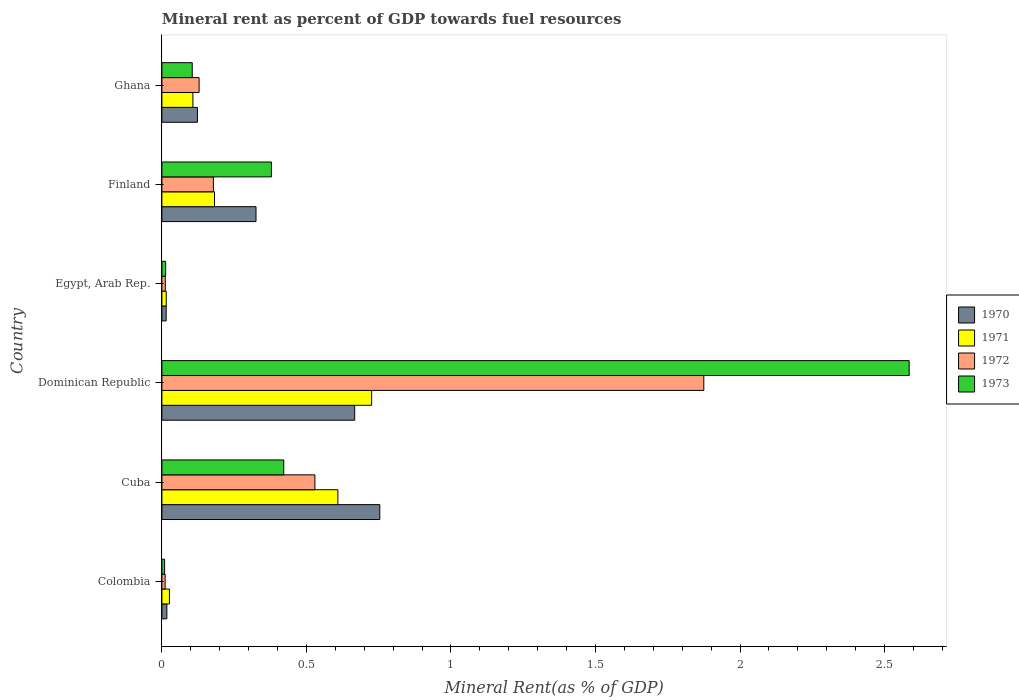How many different coloured bars are there?
Offer a very short reply. 4. How many groups of bars are there?
Offer a very short reply. 6. How many bars are there on the 3rd tick from the bottom?
Offer a very short reply. 4. What is the mineral rent in 1970 in Cuba?
Make the answer very short. 0.75. Across all countries, what is the maximum mineral rent in 1971?
Your answer should be very brief. 0.73. Across all countries, what is the minimum mineral rent in 1971?
Your response must be concise. 0.02. In which country was the mineral rent in 1972 maximum?
Provide a short and direct response. Dominican Republic. In which country was the mineral rent in 1971 minimum?
Provide a succinct answer. Egypt, Arab Rep. What is the total mineral rent in 1972 in the graph?
Your answer should be compact. 2.73. What is the difference between the mineral rent in 1971 in Cuba and that in Ghana?
Offer a very short reply. 0.5. What is the difference between the mineral rent in 1972 in Ghana and the mineral rent in 1971 in Cuba?
Make the answer very short. -0.48. What is the average mineral rent in 1972 per country?
Keep it short and to the point. 0.46. What is the difference between the mineral rent in 1972 and mineral rent in 1973 in Cuba?
Provide a succinct answer. 0.11. What is the ratio of the mineral rent in 1973 in Colombia to that in Egypt, Arab Rep.?
Provide a short and direct response. 0.72. Is the difference between the mineral rent in 1972 in Egypt, Arab Rep. and Ghana greater than the difference between the mineral rent in 1973 in Egypt, Arab Rep. and Ghana?
Offer a very short reply. No. What is the difference between the highest and the second highest mineral rent in 1971?
Make the answer very short. 0.12. What is the difference between the highest and the lowest mineral rent in 1971?
Make the answer very short. 0.71. Is the sum of the mineral rent in 1971 in Dominican Republic and Finland greater than the maximum mineral rent in 1973 across all countries?
Your answer should be very brief. No. Is it the case that in every country, the sum of the mineral rent in 1973 and mineral rent in 1971 is greater than the sum of mineral rent in 1970 and mineral rent in 1972?
Your answer should be compact. No. Are all the bars in the graph horizontal?
Provide a succinct answer. Yes. What is the difference between two consecutive major ticks on the X-axis?
Provide a short and direct response. 0.5. What is the title of the graph?
Your answer should be very brief. Mineral rent as percent of GDP towards fuel resources. Does "1982" appear as one of the legend labels in the graph?
Give a very brief answer. No. What is the label or title of the X-axis?
Provide a short and direct response. Mineral Rent(as % of GDP). What is the label or title of the Y-axis?
Offer a very short reply. Country. What is the Mineral Rent(as % of GDP) in 1970 in Colombia?
Provide a short and direct response. 0.02. What is the Mineral Rent(as % of GDP) in 1971 in Colombia?
Give a very brief answer. 0.03. What is the Mineral Rent(as % of GDP) of 1972 in Colombia?
Make the answer very short. 0.01. What is the Mineral Rent(as % of GDP) of 1973 in Colombia?
Provide a succinct answer. 0.01. What is the Mineral Rent(as % of GDP) in 1970 in Cuba?
Provide a succinct answer. 0.75. What is the Mineral Rent(as % of GDP) in 1971 in Cuba?
Provide a short and direct response. 0.61. What is the Mineral Rent(as % of GDP) in 1972 in Cuba?
Your answer should be compact. 0.53. What is the Mineral Rent(as % of GDP) of 1973 in Cuba?
Give a very brief answer. 0.42. What is the Mineral Rent(as % of GDP) in 1970 in Dominican Republic?
Offer a very short reply. 0.67. What is the Mineral Rent(as % of GDP) in 1971 in Dominican Republic?
Offer a very short reply. 0.73. What is the Mineral Rent(as % of GDP) of 1972 in Dominican Republic?
Offer a terse response. 1.87. What is the Mineral Rent(as % of GDP) of 1973 in Dominican Republic?
Your response must be concise. 2.59. What is the Mineral Rent(as % of GDP) of 1970 in Egypt, Arab Rep.?
Offer a terse response. 0.01. What is the Mineral Rent(as % of GDP) of 1971 in Egypt, Arab Rep.?
Offer a terse response. 0.02. What is the Mineral Rent(as % of GDP) of 1972 in Egypt, Arab Rep.?
Your answer should be compact. 0.01. What is the Mineral Rent(as % of GDP) in 1973 in Egypt, Arab Rep.?
Make the answer very short. 0.01. What is the Mineral Rent(as % of GDP) in 1970 in Finland?
Make the answer very short. 0.33. What is the Mineral Rent(as % of GDP) of 1971 in Finland?
Offer a very short reply. 0.18. What is the Mineral Rent(as % of GDP) of 1972 in Finland?
Your answer should be compact. 0.18. What is the Mineral Rent(as % of GDP) in 1973 in Finland?
Ensure brevity in your answer.  0.38. What is the Mineral Rent(as % of GDP) of 1970 in Ghana?
Your response must be concise. 0.12. What is the Mineral Rent(as % of GDP) in 1971 in Ghana?
Provide a short and direct response. 0.11. What is the Mineral Rent(as % of GDP) in 1972 in Ghana?
Your answer should be compact. 0.13. What is the Mineral Rent(as % of GDP) in 1973 in Ghana?
Offer a very short reply. 0.1. Across all countries, what is the maximum Mineral Rent(as % of GDP) of 1970?
Give a very brief answer. 0.75. Across all countries, what is the maximum Mineral Rent(as % of GDP) of 1971?
Your answer should be compact. 0.73. Across all countries, what is the maximum Mineral Rent(as % of GDP) of 1972?
Your answer should be very brief. 1.87. Across all countries, what is the maximum Mineral Rent(as % of GDP) in 1973?
Provide a short and direct response. 2.59. Across all countries, what is the minimum Mineral Rent(as % of GDP) in 1970?
Your answer should be compact. 0.01. Across all countries, what is the minimum Mineral Rent(as % of GDP) in 1971?
Provide a succinct answer. 0.02. Across all countries, what is the minimum Mineral Rent(as % of GDP) of 1972?
Offer a terse response. 0.01. Across all countries, what is the minimum Mineral Rent(as % of GDP) in 1973?
Your answer should be compact. 0.01. What is the total Mineral Rent(as % of GDP) of 1970 in the graph?
Give a very brief answer. 1.9. What is the total Mineral Rent(as % of GDP) in 1971 in the graph?
Your answer should be compact. 1.66. What is the total Mineral Rent(as % of GDP) of 1972 in the graph?
Your response must be concise. 2.73. What is the total Mineral Rent(as % of GDP) of 1973 in the graph?
Keep it short and to the point. 3.51. What is the difference between the Mineral Rent(as % of GDP) of 1970 in Colombia and that in Cuba?
Give a very brief answer. -0.74. What is the difference between the Mineral Rent(as % of GDP) in 1971 in Colombia and that in Cuba?
Provide a short and direct response. -0.58. What is the difference between the Mineral Rent(as % of GDP) of 1972 in Colombia and that in Cuba?
Keep it short and to the point. -0.52. What is the difference between the Mineral Rent(as % of GDP) in 1973 in Colombia and that in Cuba?
Make the answer very short. -0.41. What is the difference between the Mineral Rent(as % of GDP) in 1970 in Colombia and that in Dominican Republic?
Ensure brevity in your answer.  -0.65. What is the difference between the Mineral Rent(as % of GDP) of 1971 in Colombia and that in Dominican Republic?
Your response must be concise. -0.7. What is the difference between the Mineral Rent(as % of GDP) in 1972 in Colombia and that in Dominican Republic?
Your response must be concise. -1.86. What is the difference between the Mineral Rent(as % of GDP) in 1973 in Colombia and that in Dominican Republic?
Your answer should be compact. -2.58. What is the difference between the Mineral Rent(as % of GDP) in 1970 in Colombia and that in Egypt, Arab Rep.?
Provide a short and direct response. 0. What is the difference between the Mineral Rent(as % of GDP) of 1971 in Colombia and that in Egypt, Arab Rep.?
Offer a very short reply. 0.01. What is the difference between the Mineral Rent(as % of GDP) in 1972 in Colombia and that in Egypt, Arab Rep.?
Provide a short and direct response. -0. What is the difference between the Mineral Rent(as % of GDP) of 1973 in Colombia and that in Egypt, Arab Rep.?
Give a very brief answer. -0. What is the difference between the Mineral Rent(as % of GDP) in 1970 in Colombia and that in Finland?
Your answer should be very brief. -0.31. What is the difference between the Mineral Rent(as % of GDP) in 1971 in Colombia and that in Finland?
Your answer should be compact. -0.16. What is the difference between the Mineral Rent(as % of GDP) in 1972 in Colombia and that in Finland?
Your answer should be compact. -0.17. What is the difference between the Mineral Rent(as % of GDP) in 1973 in Colombia and that in Finland?
Offer a very short reply. -0.37. What is the difference between the Mineral Rent(as % of GDP) of 1970 in Colombia and that in Ghana?
Ensure brevity in your answer.  -0.11. What is the difference between the Mineral Rent(as % of GDP) in 1971 in Colombia and that in Ghana?
Your answer should be very brief. -0.08. What is the difference between the Mineral Rent(as % of GDP) in 1972 in Colombia and that in Ghana?
Offer a very short reply. -0.12. What is the difference between the Mineral Rent(as % of GDP) of 1973 in Colombia and that in Ghana?
Give a very brief answer. -0.1. What is the difference between the Mineral Rent(as % of GDP) of 1970 in Cuba and that in Dominican Republic?
Offer a terse response. 0.09. What is the difference between the Mineral Rent(as % of GDP) of 1971 in Cuba and that in Dominican Republic?
Offer a very short reply. -0.12. What is the difference between the Mineral Rent(as % of GDP) of 1972 in Cuba and that in Dominican Republic?
Your answer should be very brief. -1.35. What is the difference between the Mineral Rent(as % of GDP) of 1973 in Cuba and that in Dominican Republic?
Offer a terse response. -2.16. What is the difference between the Mineral Rent(as % of GDP) in 1970 in Cuba and that in Egypt, Arab Rep.?
Your answer should be compact. 0.74. What is the difference between the Mineral Rent(as % of GDP) in 1971 in Cuba and that in Egypt, Arab Rep.?
Offer a very short reply. 0.59. What is the difference between the Mineral Rent(as % of GDP) in 1972 in Cuba and that in Egypt, Arab Rep.?
Offer a very short reply. 0.52. What is the difference between the Mineral Rent(as % of GDP) of 1973 in Cuba and that in Egypt, Arab Rep.?
Provide a short and direct response. 0.41. What is the difference between the Mineral Rent(as % of GDP) of 1970 in Cuba and that in Finland?
Offer a very short reply. 0.43. What is the difference between the Mineral Rent(as % of GDP) of 1971 in Cuba and that in Finland?
Offer a terse response. 0.43. What is the difference between the Mineral Rent(as % of GDP) of 1972 in Cuba and that in Finland?
Ensure brevity in your answer.  0.35. What is the difference between the Mineral Rent(as % of GDP) of 1973 in Cuba and that in Finland?
Keep it short and to the point. 0.04. What is the difference between the Mineral Rent(as % of GDP) of 1970 in Cuba and that in Ghana?
Your answer should be compact. 0.63. What is the difference between the Mineral Rent(as % of GDP) of 1971 in Cuba and that in Ghana?
Give a very brief answer. 0.5. What is the difference between the Mineral Rent(as % of GDP) in 1972 in Cuba and that in Ghana?
Your response must be concise. 0.4. What is the difference between the Mineral Rent(as % of GDP) in 1973 in Cuba and that in Ghana?
Your answer should be compact. 0.32. What is the difference between the Mineral Rent(as % of GDP) in 1970 in Dominican Republic and that in Egypt, Arab Rep.?
Provide a succinct answer. 0.65. What is the difference between the Mineral Rent(as % of GDP) in 1971 in Dominican Republic and that in Egypt, Arab Rep.?
Your answer should be compact. 0.71. What is the difference between the Mineral Rent(as % of GDP) of 1972 in Dominican Republic and that in Egypt, Arab Rep.?
Your response must be concise. 1.86. What is the difference between the Mineral Rent(as % of GDP) in 1973 in Dominican Republic and that in Egypt, Arab Rep.?
Provide a succinct answer. 2.57. What is the difference between the Mineral Rent(as % of GDP) of 1970 in Dominican Republic and that in Finland?
Your response must be concise. 0.34. What is the difference between the Mineral Rent(as % of GDP) in 1971 in Dominican Republic and that in Finland?
Your answer should be very brief. 0.54. What is the difference between the Mineral Rent(as % of GDP) of 1972 in Dominican Republic and that in Finland?
Offer a terse response. 1.7. What is the difference between the Mineral Rent(as % of GDP) of 1973 in Dominican Republic and that in Finland?
Keep it short and to the point. 2.21. What is the difference between the Mineral Rent(as % of GDP) in 1970 in Dominican Republic and that in Ghana?
Provide a succinct answer. 0.54. What is the difference between the Mineral Rent(as % of GDP) of 1971 in Dominican Republic and that in Ghana?
Keep it short and to the point. 0.62. What is the difference between the Mineral Rent(as % of GDP) of 1972 in Dominican Republic and that in Ghana?
Give a very brief answer. 1.75. What is the difference between the Mineral Rent(as % of GDP) of 1973 in Dominican Republic and that in Ghana?
Your response must be concise. 2.48. What is the difference between the Mineral Rent(as % of GDP) of 1970 in Egypt, Arab Rep. and that in Finland?
Give a very brief answer. -0.31. What is the difference between the Mineral Rent(as % of GDP) of 1971 in Egypt, Arab Rep. and that in Finland?
Your answer should be very brief. -0.17. What is the difference between the Mineral Rent(as % of GDP) in 1972 in Egypt, Arab Rep. and that in Finland?
Your answer should be compact. -0.17. What is the difference between the Mineral Rent(as % of GDP) of 1973 in Egypt, Arab Rep. and that in Finland?
Make the answer very short. -0.37. What is the difference between the Mineral Rent(as % of GDP) in 1970 in Egypt, Arab Rep. and that in Ghana?
Make the answer very short. -0.11. What is the difference between the Mineral Rent(as % of GDP) in 1971 in Egypt, Arab Rep. and that in Ghana?
Offer a very short reply. -0.09. What is the difference between the Mineral Rent(as % of GDP) of 1972 in Egypt, Arab Rep. and that in Ghana?
Your answer should be very brief. -0.12. What is the difference between the Mineral Rent(as % of GDP) of 1973 in Egypt, Arab Rep. and that in Ghana?
Offer a very short reply. -0.09. What is the difference between the Mineral Rent(as % of GDP) of 1970 in Finland and that in Ghana?
Your response must be concise. 0.2. What is the difference between the Mineral Rent(as % of GDP) of 1971 in Finland and that in Ghana?
Your answer should be compact. 0.07. What is the difference between the Mineral Rent(as % of GDP) of 1972 in Finland and that in Ghana?
Keep it short and to the point. 0.05. What is the difference between the Mineral Rent(as % of GDP) of 1973 in Finland and that in Ghana?
Make the answer very short. 0.27. What is the difference between the Mineral Rent(as % of GDP) in 1970 in Colombia and the Mineral Rent(as % of GDP) in 1971 in Cuba?
Provide a short and direct response. -0.59. What is the difference between the Mineral Rent(as % of GDP) of 1970 in Colombia and the Mineral Rent(as % of GDP) of 1972 in Cuba?
Your answer should be very brief. -0.51. What is the difference between the Mineral Rent(as % of GDP) in 1970 in Colombia and the Mineral Rent(as % of GDP) in 1973 in Cuba?
Provide a succinct answer. -0.4. What is the difference between the Mineral Rent(as % of GDP) of 1971 in Colombia and the Mineral Rent(as % of GDP) of 1972 in Cuba?
Make the answer very short. -0.5. What is the difference between the Mineral Rent(as % of GDP) in 1971 in Colombia and the Mineral Rent(as % of GDP) in 1973 in Cuba?
Ensure brevity in your answer.  -0.4. What is the difference between the Mineral Rent(as % of GDP) of 1972 in Colombia and the Mineral Rent(as % of GDP) of 1973 in Cuba?
Offer a terse response. -0.41. What is the difference between the Mineral Rent(as % of GDP) of 1970 in Colombia and the Mineral Rent(as % of GDP) of 1971 in Dominican Republic?
Ensure brevity in your answer.  -0.71. What is the difference between the Mineral Rent(as % of GDP) of 1970 in Colombia and the Mineral Rent(as % of GDP) of 1972 in Dominican Republic?
Offer a very short reply. -1.86. What is the difference between the Mineral Rent(as % of GDP) in 1970 in Colombia and the Mineral Rent(as % of GDP) in 1973 in Dominican Republic?
Make the answer very short. -2.57. What is the difference between the Mineral Rent(as % of GDP) of 1971 in Colombia and the Mineral Rent(as % of GDP) of 1972 in Dominican Republic?
Offer a terse response. -1.85. What is the difference between the Mineral Rent(as % of GDP) in 1971 in Colombia and the Mineral Rent(as % of GDP) in 1973 in Dominican Republic?
Give a very brief answer. -2.56. What is the difference between the Mineral Rent(as % of GDP) in 1972 in Colombia and the Mineral Rent(as % of GDP) in 1973 in Dominican Republic?
Your response must be concise. -2.57. What is the difference between the Mineral Rent(as % of GDP) of 1970 in Colombia and the Mineral Rent(as % of GDP) of 1971 in Egypt, Arab Rep.?
Give a very brief answer. 0. What is the difference between the Mineral Rent(as % of GDP) of 1970 in Colombia and the Mineral Rent(as % of GDP) of 1972 in Egypt, Arab Rep.?
Provide a succinct answer. 0.01. What is the difference between the Mineral Rent(as % of GDP) in 1970 in Colombia and the Mineral Rent(as % of GDP) in 1973 in Egypt, Arab Rep.?
Offer a terse response. 0. What is the difference between the Mineral Rent(as % of GDP) of 1971 in Colombia and the Mineral Rent(as % of GDP) of 1972 in Egypt, Arab Rep.?
Provide a succinct answer. 0.01. What is the difference between the Mineral Rent(as % of GDP) in 1971 in Colombia and the Mineral Rent(as % of GDP) in 1973 in Egypt, Arab Rep.?
Make the answer very short. 0.01. What is the difference between the Mineral Rent(as % of GDP) in 1972 in Colombia and the Mineral Rent(as % of GDP) in 1973 in Egypt, Arab Rep.?
Make the answer very short. -0. What is the difference between the Mineral Rent(as % of GDP) in 1970 in Colombia and the Mineral Rent(as % of GDP) in 1971 in Finland?
Make the answer very short. -0.16. What is the difference between the Mineral Rent(as % of GDP) in 1970 in Colombia and the Mineral Rent(as % of GDP) in 1972 in Finland?
Keep it short and to the point. -0.16. What is the difference between the Mineral Rent(as % of GDP) of 1970 in Colombia and the Mineral Rent(as % of GDP) of 1973 in Finland?
Make the answer very short. -0.36. What is the difference between the Mineral Rent(as % of GDP) of 1971 in Colombia and the Mineral Rent(as % of GDP) of 1972 in Finland?
Provide a short and direct response. -0.15. What is the difference between the Mineral Rent(as % of GDP) of 1971 in Colombia and the Mineral Rent(as % of GDP) of 1973 in Finland?
Provide a succinct answer. -0.35. What is the difference between the Mineral Rent(as % of GDP) of 1972 in Colombia and the Mineral Rent(as % of GDP) of 1973 in Finland?
Your response must be concise. -0.37. What is the difference between the Mineral Rent(as % of GDP) in 1970 in Colombia and the Mineral Rent(as % of GDP) in 1971 in Ghana?
Give a very brief answer. -0.09. What is the difference between the Mineral Rent(as % of GDP) in 1970 in Colombia and the Mineral Rent(as % of GDP) in 1972 in Ghana?
Ensure brevity in your answer.  -0.11. What is the difference between the Mineral Rent(as % of GDP) of 1970 in Colombia and the Mineral Rent(as % of GDP) of 1973 in Ghana?
Ensure brevity in your answer.  -0.09. What is the difference between the Mineral Rent(as % of GDP) in 1971 in Colombia and the Mineral Rent(as % of GDP) in 1972 in Ghana?
Your answer should be compact. -0.1. What is the difference between the Mineral Rent(as % of GDP) in 1971 in Colombia and the Mineral Rent(as % of GDP) in 1973 in Ghana?
Provide a short and direct response. -0.08. What is the difference between the Mineral Rent(as % of GDP) of 1972 in Colombia and the Mineral Rent(as % of GDP) of 1973 in Ghana?
Keep it short and to the point. -0.09. What is the difference between the Mineral Rent(as % of GDP) of 1970 in Cuba and the Mineral Rent(as % of GDP) of 1971 in Dominican Republic?
Your response must be concise. 0.03. What is the difference between the Mineral Rent(as % of GDP) of 1970 in Cuba and the Mineral Rent(as % of GDP) of 1972 in Dominican Republic?
Keep it short and to the point. -1.12. What is the difference between the Mineral Rent(as % of GDP) in 1970 in Cuba and the Mineral Rent(as % of GDP) in 1973 in Dominican Republic?
Offer a very short reply. -1.83. What is the difference between the Mineral Rent(as % of GDP) in 1971 in Cuba and the Mineral Rent(as % of GDP) in 1972 in Dominican Republic?
Your response must be concise. -1.27. What is the difference between the Mineral Rent(as % of GDP) in 1971 in Cuba and the Mineral Rent(as % of GDP) in 1973 in Dominican Republic?
Provide a succinct answer. -1.98. What is the difference between the Mineral Rent(as % of GDP) of 1972 in Cuba and the Mineral Rent(as % of GDP) of 1973 in Dominican Republic?
Give a very brief answer. -2.06. What is the difference between the Mineral Rent(as % of GDP) in 1970 in Cuba and the Mineral Rent(as % of GDP) in 1971 in Egypt, Arab Rep.?
Ensure brevity in your answer.  0.74. What is the difference between the Mineral Rent(as % of GDP) in 1970 in Cuba and the Mineral Rent(as % of GDP) in 1972 in Egypt, Arab Rep.?
Provide a succinct answer. 0.74. What is the difference between the Mineral Rent(as % of GDP) of 1970 in Cuba and the Mineral Rent(as % of GDP) of 1973 in Egypt, Arab Rep.?
Your answer should be very brief. 0.74. What is the difference between the Mineral Rent(as % of GDP) in 1971 in Cuba and the Mineral Rent(as % of GDP) in 1972 in Egypt, Arab Rep.?
Your answer should be very brief. 0.6. What is the difference between the Mineral Rent(as % of GDP) of 1971 in Cuba and the Mineral Rent(as % of GDP) of 1973 in Egypt, Arab Rep.?
Your answer should be compact. 0.6. What is the difference between the Mineral Rent(as % of GDP) in 1972 in Cuba and the Mineral Rent(as % of GDP) in 1973 in Egypt, Arab Rep.?
Your answer should be very brief. 0.52. What is the difference between the Mineral Rent(as % of GDP) in 1970 in Cuba and the Mineral Rent(as % of GDP) in 1971 in Finland?
Provide a succinct answer. 0.57. What is the difference between the Mineral Rent(as % of GDP) of 1970 in Cuba and the Mineral Rent(as % of GDP) of 1972 in Finland?
Provide a short and direct response. 0.58. What is the difference between the Mineral Rent(as % of GDP) of 1970 in Cuba and the Mineral Rent(as % of GDP) of 1973 in Finland?
Offer a terse response. 0.37. What is the difference between the Mineral Rent(as % of GDP) of 1971 in Cuba and the Mineral Rent(as % of GDP) of 1972 in Finland?
Your answer should be compact. 0.43. What is the difference between the Mineral Rent(as % of GDP) in 1971 in Cuba and the Mineral Rent(as % of GDP) in 1973 in Finland?
Offer a very short reply. 0.23. What is the difference between the Mineral Rent(as % of GDP) of 1972 in Cuba and the Mineral Rent(as % of GDP) of 1973 in Finland?
Provide a succinct answer. 0.15. What is the difference between the Mineral Rent(as % of GDP) of 1970 in Cuba and the Mineral Rent(as % of GDP) of 1971 in Ghana?
Your answer should be compact. 0.65. What is the difference between the Mineral Rent(as % of GDP) of 1970 in Cuba and the Mineral Rent(as % of GDP) of 1972 in Ghana?
Your response must be concise. 0.62. What is the difference between the Mineral Rent(as % of GDP) of 1970 in Cuba and the Mineral Rent(as % of GDP) of 1973 in Ghana?
Offer a terse response. 0.65. What is the difference between the Mineral Rent(as % of GDP) of 1971 in Cuba and the Mineral Rent(as % of GDP) of 1972 in Ghana?
Keep it short and to the point. 0.48. What is the difference between the Mineral Rent(as % of GDP) in 1971 in Cuba and the Mineral Rent(as % of GDP) in 1973 in Ghana?
Provide a succinct answer. 0.5. What is the difference between the Mineral Rent(as % of GDP) of 1972 in Cuba and the Mineral Rent(as % of GDP) of 1973 in Ghana?
Keep it short and to the point. 0.42. What is the difference between the Mineral Rent(as % of GDP) in 1970 in Dominican Republic and the Mineral Rent(as % of GDP) in 1971 in Egypt, Arab Rep.?
Your answer should be very brief. 0.65. What is the difference between the Mineral Rent(as % of GDP) of 1970 in Dominican Republic and the Mineral Rent(as % of GDP) of 1972 in Egypt, Arab Rep.?
Provide a succinct answer. 0.66. What is the difference between the Mineral Rent(as % of GDP) in 1970 in Dominican Republic and the Mineral Rent(as % of GDP) in 1973 in Egypt, Arab Rep.?
Your answer should be compact. 0.65. What is the difference between the Mineral Rent(as % of GDP) in 1971 in Dominican Republic and the Mineral Rent(as % of GDP) in 1972 in Egypt, Arab Rep.?
Your answer should be very brief. 0.71. What is the difference between the Mineral Rent(as % of GDP) in 1971 in Dominican Republic and the Mineral Rent(as % of GDP) in 1973 in Egypt, Arab Rep.?
Offer a very short reply. 0.71. What is the difference between the Mineral Rent(as % of GDP) in 1972 in Dominican Republic and the Mineral Rent(as % of GDP) in 1973 in Egypt, Arab Rep.?
Give a very brief answer. 1.86. What is the difference between the Mineral Rent(as % of GDP) in 1970 in Dominican Republic and the Mineral Rent(as % of GDP) in 1971 in Finland?
Provide a succinct answer. 0.48. What is the difference between the Mineral Rent(as % of GDP) in 1970 in Dominican Republic and the Mineral Rent(as % of GDP) in 1972 in Finland?
Give a very brief answer. 0.49. What is the difference between the Mineral Rent(as % of GDP) of 1970 in Dominican Republic and the Mineral Rent(as % of GDP) of 1973 in Finland?
Provide a succinct answer. 0.29. What is the difference between the Mineral Rent(as % of GDP) in 1971 in Dominican Republic and the Mineral Rent(as % of GDP) in 1972 in Finland?
Your answer should be very brief. 0.55. What is the difference between the Mineral Rent(as % of GDP) in 1971 in Dominican Republic and the Mineral Rent(as % of GDP) in 1973 in Finland?
Keep it short and to the point. 0.35. What is the difference between the Mineral Rent(as % of GDP) in 1972 in Dominican Republic and the Mineral Rent(as % of GDP) in 1973 in Finland?
Your answer should be very brief. 1.5. What is the difference between the Mineral Rent(as % of GDP) in 1970 in Dominican Republic and the Mineral Rent(as % of GDP) in 1971 in Ghana?
Your response must be concise. 0.56. What is the difference between the Mineral Rent(as % of GDP) in 1970 in Dominican Republic and the Mineral Rent(as % of GDP) in 1972 in Ghana?
Provide a succinct answer. 0.54. What is the difference between the Mineral Rent(as % of GDP) in 1970 in Dominican Republic and the Mineral Rent(as % of GDP) in 1973 in Ghana?
Your response must be concise. 0.56. What is the difference between the Mineral Rent(as % of GDP) of 1971 in Dominican Republic and the Mineral Rent(as % of GDP) of 1972 in Ghana?
Give a very brief answer. 0.6. What is the difference between the Mineral Rent(as % of GDP) in 1971 in Dominican Republic and the Mineral Rent(as % of GDP) in 1973 in Ghana?
Provide a short and direct response. 0.62. What is the difference between the Mineral Rent(as % of GDP) of 1972 in Dominican Republic and the Mineral Rent(as % of GDP) of 1973 in Ghana?
Your answer should be very brief. 1.77. What is the difference between the Mineral Rent(as % of GDP) in 1970 in Egypt, Arab Rep. and the Mineral Rent(as % of GDP) in 1971 in Finland?
Ensure brevity in your answer.  -0.17. What is the difference between the Mineral Rent(as % of GDP) in 1970 in Egypt, Arab Rep. and the Mineral Rent(as % of GDP) in 1972 in Finland?
Provide a short and direct response. -0.16. What is the difference between the Mineral Rent(as % of GDP) of 1970 in Egypt, Arab Rep. and the Mineral Rent(as % of GDP) of 1973 in Finland?
Keep it short and to the point. -0.36. What is the difference between the Mineral Rent(as % of GDP) in 1971 in Egypt, Arab Rep. and the Mineral Rent(as % of GDP) in 1972 in Finland?
Your answer should be very brief. -0.16. What is the difference between the Mineral Rent(as % of GDP) in 1971 in Egypt, Arab Rep. and the Mineral Rent(as % of GDP) in 1973 in Finland?
Keep it short and to the point. -0.36. What is the difference between the Mineral Rent(as % of GDP) of 1972 in Egypt, Arab Rep. and the Mineral Rent(as % of GDP) of 1973 in Finland?
Ensure brevity in your answer.  -0.37. What is the difference between the Mineral Rent(as % of GDP) of 1970 in Egypt, Arab Rep. and the Mineral Rent(as % of GDP) of 1971 in Ghana?
Make the answer very short. -0.09. What is the difference between the Mineral Rent(as % of GDP) of 1970 in Egypt, Arab Rep. and the Mineral Rent(as % of GDP) of 1972 in Ghana?
Ensure brevity in your answer.  -0.11. What is the difference between the Mineral Rent(as % of GDP) in 1970 in Egypt, Arab Rep. and the Mineral Rent(as % of GDP) in 1973 in Ghana?
Offer a terse response. -0.09. What is the difference between the Mineral Rent(as % of GDP) in 1971 in Egypt, Arab Rep. and the Mineral Rent(as % of GDP) in 1972 in Ghana?
Offer a very short reply. -0.11. What is the difference between the Mineral Rent(as % of GDP) in 1971 in Egypt, Arab Rep. and the Mineral Rent(as % of GDP) in 1973 in Ghana?
Make the answer very short. -0.09. What is the difference between the Mineral Rent(as % of GDP) in 1972 in Egypt, Arab Rep. and the Mineral Rent(as % of GDP) in 1973 in Ghana?
Give a very brief answer. -0.09. What is the difference between the Mineral Rent(as % of GDP) of 1970 in Finland and the Mineral Rent(as % of GDP) of 1971 in Ghana?
Your answer should be compact. 0.22. What is the difference between the Mineral Rent(as % of GDP) of 1970 in Finland and the Mineral Rent(as % of GDP) of 1972 in Ghana?
Your response must be concise. 0.2. What is the difference between the Mineral Rent(as % of GDP) of 1970 in Finland and the Mineral Rent(as % of GDP) of 1973 in Ghana?
Provide a succinct answer. 0.22. What is the difference between the Mineral Rent(as % of GDP) in 1971 in Finland and the Mineral Rent(as % of GDP) in 1972 in Ghana?
Provide a short and direct response. 0.05. What is the difference between the Mineral Rent(as % of GDP) of 1971 in Finland and the Mineral Rent(as % of GDP) of 1973 in Ghana?
Keep it short and to the point. 0.08. What is the difference between the Mineral Rent(as % of GDP) of 1972 in Finland and the Mineral Rent(as % of GDP) of 1973 in Ghana?
Keep it short and to the point. 0.07. What is the average Mineral Rent(as % of GDP) in 1970 per country?
Keep it short and to the point. 0.32. What is the average Mineral Rent(as % of GDP) in 1971 per country?
Provide a short and direct response. 0.28. What is the average Mineral Rent(as % of GDP) of 1972 per country?
Your response must be concise. 0.46. What is the average Mineral Rent(as % of GDP) of 1973 per country?
Keep it short and to the point. 0.59. What is the difference between the Mineral Rent(as % of GDP) of 1970 and Mineral Rent(as % of GDP) of 1971 in Colombia?
Give a very brief answer. -0.01. What is the difference between the Mineral Rent(as % of GDP) in 1970 and Mineral Rent(as % of GDP) in 1972 in Colombia?
Provide a succinct answer. 0.01. What is the difference between the Mineral Rent(as % of GDP) of 1970 and Mineral Rent(as % of GDP) of 1973 in Colombia?
Provide a short and direct response. 0.01. What is the difference between the Mineral Rent(as % of GDP) of 1971 and Mineral Rent(as % of GDP) of 1972 in Colombia?
Make the answer very short. 0.01. What is the difference between the Mineral Rent(as % of GDP) of 1971 and Mineral Rent(as % of GDP) of 1973 in Colombia?
Provide a short and direct response. 0.02. What is the difference between the Mineral Rent(as % of GDP) in 1972 and Mineral Rent(as % of GDP) in 1973 in Colombia?
Give a very brief answer. 0. What is the difference between the Mineral Rent(as % of GDP) in 1970 and Mineral Rent(as % of GDP) in 1971 in Cuba?
Provide a short and direct response. 0.14. What is the difference between the Mineral Rent(as % of GDP) of 1970 and Mineral Rent(as % of GDP) of 1972 in Cuba?
Your answer should be very brief. 0.22. What is the difference between the Mineral Rent(as % of GDP) of 1970 and Mineral Rent(as % of GDP) of 1973 in Cuba?
Offer a very short reply. 0.33. What is the difference between the Mineral Rent(as % of GDP) of 1971 and Mineral Rent(as % of GDP) of 1972 in Cuba?
Offer a terse response. 0.08. What is the difference between the Mineral Rent(as % of GDP) in 1971 and Mineral Rent(as % of GDP) in 1973 in Cuba?
Keep it short and to the point. 0.19. What is the difference between the Mineral Rent(as % of GDP) of 1972 and Mineral Rent(as % of GDP) of 1973 in Cuba?
Offer a terse response. 0.11. What is the difference between the Mineral Rent(as % of GDP) in 1970 and Mineral Rent(as % of GDP) in 1971 in Dominican Republic?
Your answer should be very brief. -0.06. What is the difference between the Mineral Rent(as % of GDP) in 1970 and Mineral Rent(as % of GDP) in 1972 in Dominican Republic?
Make the answer very short. -1.21. What is the difference between the Mineral Rent(as % of GDP) of 1970 and Mineral Rent(as % of GDP) of 1973 in Dominican Republic?
Ensure brevity in your answer.  -1.92. What is the difference between the Mineral Rent(as % of GDP) of 1971 and Mineral Rent(as % of GDP) of 1972 in Dominican Republic?
Provide a short and direct response. -1.15. What is the difference between the Mineral Rent(as % of GDP) in 1971 and Mineral Rent(as % of GDP) in 1973 in Dominican Republic?
Keep it short and to the point. -1.86. What is the difference between the Mineral Rent(as % of GDP) of 1972 and Mineral Rent(as % of GDP) of 1973 in Dominican Republic?
Make the answer very short. -0.71. What is the difference between the Mineral Rent(as % of GDP) of 1970 and Mineral Rent(as % of GDP) of 1971 in Egypt, Arab Rep.?
Give a very brief answer. -0. What is the difference between the Mineral Rent(as % of GDP) of 1970 and Mineral Rent(as % of GDP) of 1972 in Egypt, Arab Rep.?
Your answer should be very brief. 0. What is the difference between the Mineral Rent(as % of GDP) in 1970 and Mineral Rent(as % of GDP) in 1973 in Egypt, Arab Rep.?
Provide a succinct answer. 0. What is the difference between the Mineral Rent(as % of GDP) of 1971 and Mineral Rent(as % of GDP) of 1972 in Egypt, Arab Rep.?
Keep it short and to the point. 0. What is the difference between the Mineral Rent(as % of GDP) of 1971 and Mineral Rent(as % of GDP) of 1973 in Egypt, Arab Rep.?
Your response must be concise. 0. What is the difference between the Mineral Rent(as % of GDP) of 1972 and Mineral Rent(as % of GDP) of 1973 in Egypt, Arab Rep.?
Offer a very short reply. -0. What is the difference between the Mineral Rent(as % of GDP) in 1970 and Mineral Rent(as % of GDP) in 1971 in Finland?
Give a very brief answer. 0.14. What is the difference between the Mineral Rent(as % of GDP) in 1970 and Mineral Rent(as % of GDP) in 1972 in Finland?
Provide a succinct answer. 0.15. What is the difference between the Mineral Rent(as % of GDP) of 1970 and Mineral Rent(as % of GDP) of 1973 in Finland?
Provide a succinct answer. -0.05. What is the difference between the Mineral Rent(as % of GDP) of 1971 and Mineral Rent(as % of GDP) of 1972 in Finland?
Ensure brevity in your answer.  0. What is the difference between the Mineral Rent(as % of GDP) of 1971 and Mineral Rent(as % of GDP) of 1973 in Finland?
Your answer should be very brief. -0.2. What is the difference between the Mineral Rent(as % of GDP) in 1972 and Mineral Rent(as % of GDP) in 1973 in Finland?
Make the answer very short. -0.2. What is the difference between the Mineral Rent(as % of GDP) in 1970 and Mineral Rent(as % of GDP) in 1971 in Ghana?
Keep it short and to the point. 0.02. What is the difference between the Mineral Rent(as % of GDP) of 1970 and Mineral Rent(as % of GDP) of 1972 in Ghana?
Provide a succinct answer. -0.01. What is the difference between the Mineral Rent(as % of GDP) in 1970 and Mineral Rent(as % of GDP) in 1973 in Ghana?
Your answer should be very brief. 0.02. What is the difference between the Mineral Rent(as % of GDP) in 1971 and Mineral Rent(as % of GDP) in 1972 in Ghana?
Offer a terse response. -0.02. What is the difference between the Mineral Rent(as % of GDP) of 1971 and Mineral Rent(as % of GDP) of 1973 in Ghana?
Provide a succinct answer. 0. What is the difference between the Mineral Rent(as % of GDP) in 1972 and Mineral Rent(as % of GDP) in 1973 in Ghana?
Offer a very short reply. 0.02. What is the ratio of the Mineral Rent(as % of GDP) of 1970 in Colombia to that in Cuba?
Your answer should be very brief. 0.02. What is the ratio of the Mineral Rent(as % of GDP) of 1971 in Colombia to that in Cuba?
Make the answer very short. 0.04. What is the ratio of the Mineral Rent(as % of GDP) in 1972 in Colombia to that in Cuba?
Your answer should be compact. 0.02. What is the ratio of the Mineral Rent(as % of GDP) in 1973 in Colombia to that in Cuba?
Provide a succinct answer. 0.02. What is the ratio of the Mineral Rent(as % of GDP) of 1970 in Colombia to that in Dominican Republic?
Provide a succinct answer. 0.03. What is the ratio of the Mineral Rent(as % of GDP) in 1971 in Colombia to that in Dominican Republic?
Your answer should be very brief. 0.04. What is the ratio of the Mineral Rent(as % of GDP) in 1972 in Colombia to that in Dominican Republic?
Provide a short and direct response. 0.01. What is the ratio of the Mineral Rent(as % of GDP) of 1973 in Colombia to that in Dominican Republic?
Make the answer very short. 0. What is the ratio of the Mineral Rent(as % of GDP) of 1970 in Colombia to that in Egypt, Arab Rep.?
Offer a terse response. 1.16. What is the ratio of the Mineral Rent(as % of GDP) in 1971 in Colombia to that in Egypt, Arab Rep.?
Your response must be concise. 1.74. What is the ratio of the Mineral Rent(as % of GDP) in 1972 in Colombia to that in Egypt, Arab Rep.?
Your answer should be very brief. 0.95. What is the ratio of the Mineral Rent(as % of GDP) of 1973 in Colombia to that in Egypt, Arab Rep.?
Make the answer very short. 0.72. What is the ratio of the Mineral Rent(as % of GDP) of 1970 in Colombia to that in Finland?
Give a very brief answer. 0.05. What is the ratio of the Mineral Rent(as % of GDP) of 1971 in Colombia to that in Finland?
Your answer should be compact. 0.14. What is the ratio of the Mineral Rent(as % of GDP) of 1972 in Colombia to that in Finland?
Offer a very short reply. 0.06. What is the ratio of the Mineral Rent(as % of GDP) in 1973 in Colombia to that in Finland?
Provide a succinct answer. 0.02. What is the ratio of the Mineral Rent(as % of GDP) in 1970 in Colombia to that in Ghana?
Offer a very short reply. 0.14. What is the ratio of the Mineral Rent(as % of GDP) of 1971 in Colombia to that in Ghana?
Your answer should be compact. 0.24. What is the ratio of the Mineral Rent(as % of GDP) in 1972 in Colombia to that in Ghana?
Make the answer very short. 0.09. What is the ratio of the Mineral Rent(as % of GDP) in 1973 in Colombia to that in Ghana?
Provide a succinct answer. 0.09. What is the ratio of the Mineral Rent(as % of GDP) in 1970 in Cuba to that in Dominican Republic?
Give a very brief answer. 1.13. What is the ratio of the Mineral Rent(as % of GDP) of 1971 in Cuba to that in Dominican Republic?
Ensure brevity in your answer.  0.84. What is the ratio of the Mineral Rent(as % of GDP) of 1972 in Cuba to that in Dominican Republic?
Your answer should be compact. 0.28. What is the ratio of the Mineral Rent(as % of GDP) in 1973 in Cuba to that in Dominican Republic?
Offer a very short reply. 0.16. What is the ratio of the Mineral Rent(as % of GDP) of 1970 in Cuba to that in Egypt, Arab Rep.?
Ensure brevity in your answer.  51. What is the ratio of the Mineral Rent(as % of GDP) in 1971 in Cuba to that in Egypt, Arab Rep.?
Make the answer very short. 40.5. What is the ratio of the Mineral Rent(as % of GDP) of 1972 in Cuba to that in Egypt, Arab Rep.?
Offer a very short reply. 45.11. What is the ratio of the Mineral Rent(as % of GDP) in 1973 in Cuba to that in Egypt, Arab Rep.?
Make the answer very short. 32.3. What is the ratio of the Mineral Rent(as % of GDP) of 1970 in Cuba to that in Finland?
Provide a succinct answer. 2.32. What is the ratio of the Mineral Rent(as % of GDP) of 1971 in Cuba to that in Finland?
Offer a terse response. 3.34. What is the ratio of the Mineral Rent(as % of GDP) of 1972 in Cuba to that in Finland?
Ensure brevity in your answer.  2.97. What is the ratio of the Mineral Rent(as % of GDP) in 1973 in Cuba to that in Finland?
Offer a terse response. 1.11. What is the ratio of the Mineral Rent(as % of GDP) of 1970 in Cuba to that in Ghana?
Provide a short and direct response. 6.13. What is the ratio of the Mineral Rent(as % of GDP) of 1971 in Cuba to that in Ghana?
Offer a very short reply. 5.68. What is the ratio of the Mineral Rent(as % of GDP) in 1972 in Cuba to that in Ghana?
Offer a terse response. 4.11. What is the ratio of the Mineral Rent(as % of GDP) of 1973 in Cuba to that in Ghana?
Make the answer very short. 4.02. What is the ratio of the Mineral Rent(as % of GDP) of 1970 in Dominican Republic to that in Egypt, Arab Rep.?
Make the answer very short. 45.13. What is the ratio of the Mineral Rent(as % of GDP) of 1971 in Dominican Republic to that in Egypt, Arab Rep.?
Your answer should be very brief. 48.27. What is the ratio of the Mineral Rent(as % of GDP) in 1972 in Dominican Republic to that in Egypt, Arab Rep.?
Your response must be concise. 159.8. What is the ratio of the Mineral Rent(as % of GDP) of 1973 in Dominican Republic to that in Egypt, Arab Rep.?
Provide a short and direct response. 198.1. What is the ratio of the Mineral Rent(as % of GDP) in 1970 in Dominican Republic to that in Finland?
Make the answer very short. 2.05. What is the ratio of the Mineral Rent(as % of GDP) in 1971 in Dominican Republic to that in Finland?
Make the answer very short. 3.99. What is the ratio of the Mineral Rent(as % of GDP) of 1972 in Dominican Republic to that in Finland?
Offer a terse response. 10.53. What is the ratio of the Mineral Rent(as % of GDP) of 1973 in Dominican Republic to that in Finland?
Make the answer very short. 6.82. What is the ratio of the Mineral Rent(as % of GDP) of 1970 in Dominican Republic to that in Ghana?
Your response must be concise. 5.42. What is the ratio of the Mineral Rent(as % of GDP) in 1971 in Dominican Republic to that in Ghana?
Ensure brevity in your answer.  6.77. What is the ratio of the Mineral Rent(as % of GDP) in 1972 in Dominican Republic to that in Ghana?
Your answer should be very brief. 14.57. What is the ratio of the Mineral Rent(as % of GDP) of 1973 in Dominican Republic to that in Ghana?
Ensure brevity in your answer.  24.64. What is the ratio of the Mineral Rent(as % of GDP) in 1970 in Egypt, Arab Rep. to that in Finland?
Make the answer very short. 0.05. What is the ratio of the Mineral Rent(as % of GDP) of 1971 in Egypt, Arab Rep. to that in Finland?
Keep it short and to the point. 0.08. What is the ratio of the Mineral Rent(as % of GDP) of 1972 in Egypt, Arab Rep. to that in Finland?
Provide a succinct answer. 0.07. What is the ratio of the Mineral Rent(as % of GDP) in 1973 in Egypt, Arab Rep. to that in Finland?
Offer a terse response. 0.03. What is the ratio of the Mineral Rent(as % of GDP) in 1970 in Egypt, Arab Rep. to that in Ghana?
Offer a very short reply. 0.12. What is the ratio of the Mineral Rent(as % of GDP) of 1971 in Egypt, Arab Rep. to that in Ghana?
Provide a short and direct response. 0.14. What is the ratio of the Mineral Rent(as % of GDP) in 1972 in Egypt, Arab Rep. to that in Ghana?
Make the answer very short. 0.09. What is the ratio of the Mineral Rent(as % of GDP) of 1973 in Egypt, Arab Rep. to that in Ghana?
Your answer should be very brief. 0.12. What is the ratio of the Mineral Rent(as % of GDP) in 1970 in Finland to that in Ghana?
Your answer should be very brief. 2.65. What is the ratio of the Mineral Rent(as % of GDP) in 1971 in Finland to that in Ghana?
Give a very brief answer. 1.7. What is the ratio of the Mineral Rent(as % of GDP) of 1972 in Finland to that in Ghana?
Make the answer very short. 1.38. What is the ratio of the Mineral Rent(as % of GDP) in 1973 in Finland to that in Ghana?
Your response must be concise. 3.61. What is the difference between the highest and the second highest Mineral Rent(as % of GDP) of 1970?
Your response must be concise. 0.09. What is the difference between the highest and the second highest Mineral Rent(as % of GDP) of 1971?
Offer a very short reply. 0.12. What is the difference between the highest and the second highest Mineral Rent(as % of GDP) of 1972?
Give a very brief answer. 1.35. What is the difference between the highest and the second highest Mineral Rent(as % of GDP) in 1973?
Provide a short and direct response. 2.16. What is the difference between the highest and the lowest Mineral Rent(as % of GDP) of 1970?
Ensure brevity in your answer.  0.74. What is the difference between the highest and the lowest Mineral Rent(as % of GDP) of 1971?
Provide a short and direct response. 0.71. What is the difference between the highest and the lowest Mineral Rent(as % of GDP) in 1972?
Give a very brief answer. 1.86. What is the difference between the highest and the lowest Mineral Rent(as % of GDP) of 1973?
Provide a succinct answer. 2.58. 